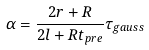Convert formula to latex. <formula><loc_0><loc_0><loc_500><loc_500>\alpha = \frac { 2 r + R } { 2 l + R t _ { p r e } } \tau _ { g a u s s }</formula> 